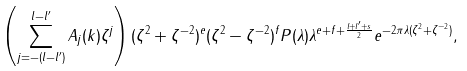<formula> <loc_0><loc_0><loc_500><loc_500>\left ( \sum _ { j = - ( l - l ^ { \prime } ) } ^ { l - l ^ { \prime } } A _ { j } ( k ) \zeta ^ { j } \right ) ( \zeta ^ { 2 } + \zeta ^ { - 2 } ) ^ { e } ( \zeta ^ { 2 } - \zeta ^ { - 2 } ) ^ { f } P ( \lambda ) \lambda ^ { e + f + \frac { l + l ^ { \prime } + s } 2 } e ^ { - 2 \pi \lambda ( \zeta ^ { 2 } + \zeta ^ { - 2 } ) } ,</formula> 